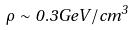Convert formula to latex. <formula><loc_0><loc_0><loc_500><loc_500>\rho \sim 0 . 3 G e V / c m ^ { 3 }</formula> 